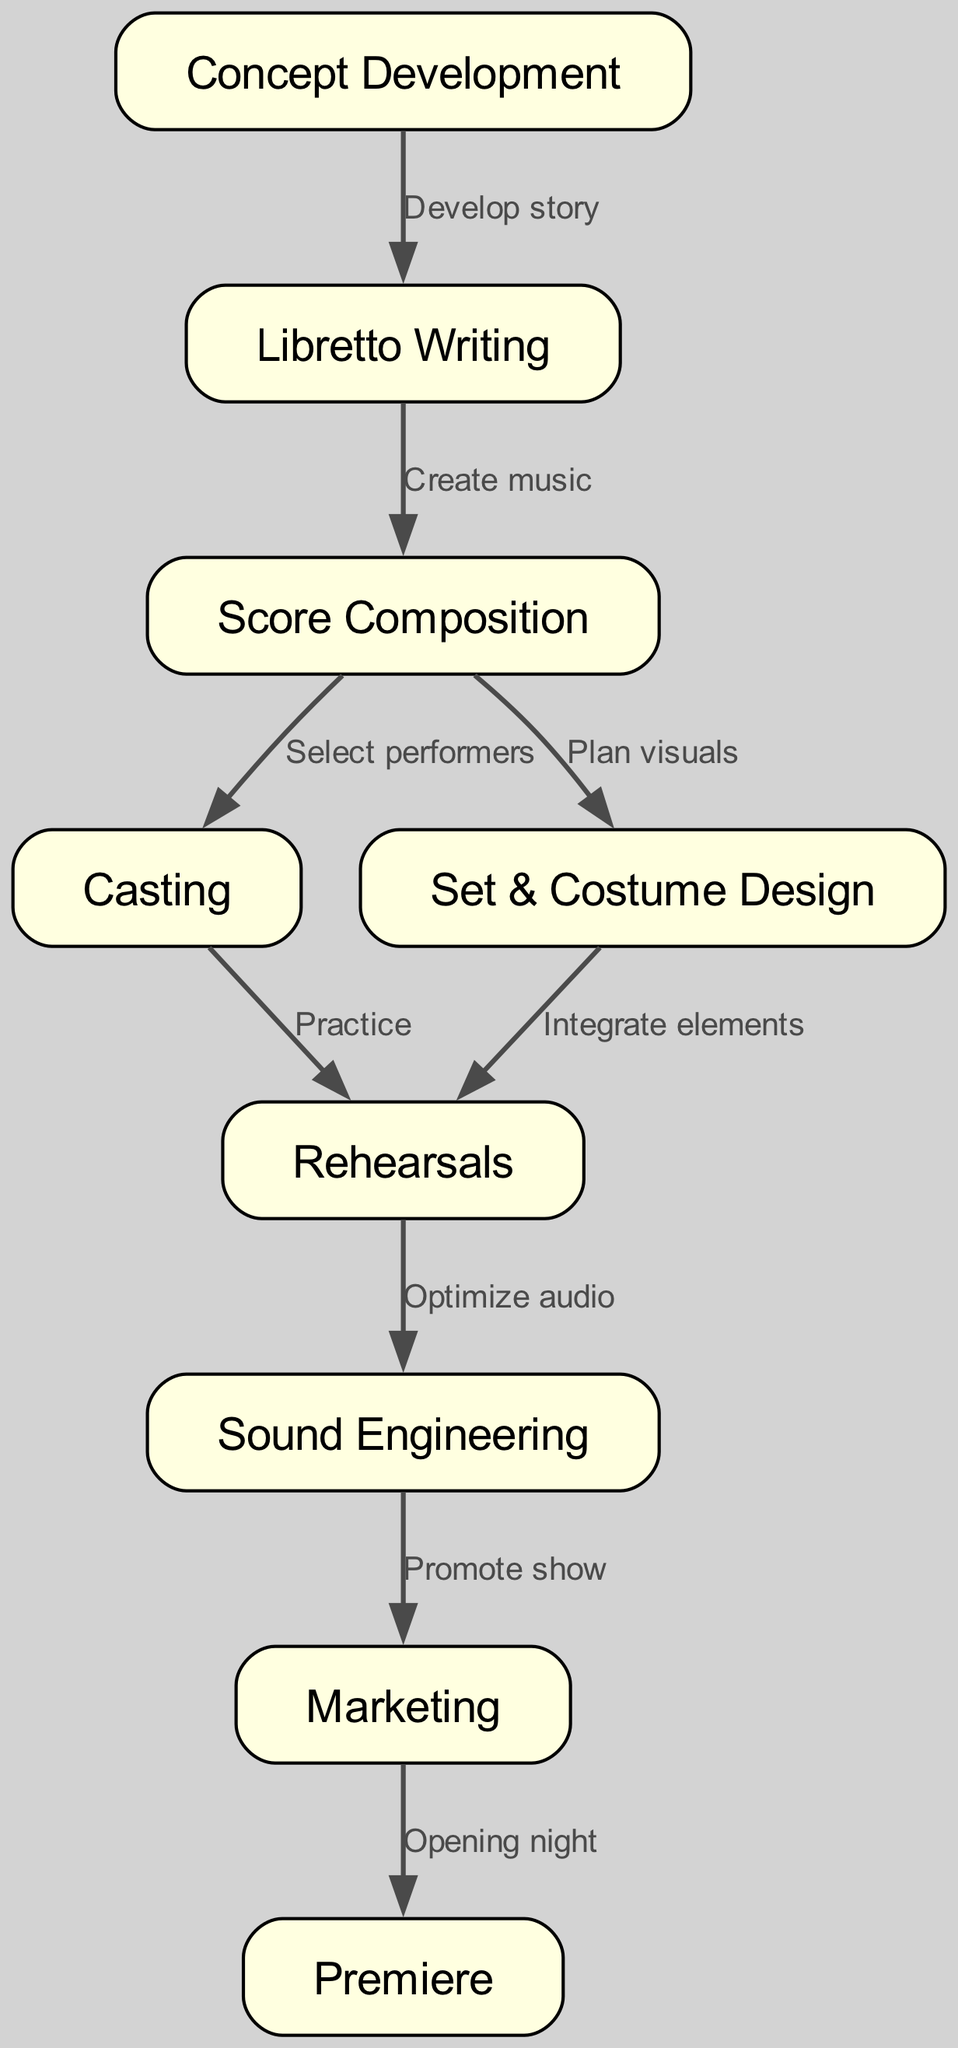What are the first two stages in modern opera production? The first two stages in the flow chart are "Concept Development" and "Libretto Writing". To determine this, we start from the top of the diagram and simply identify the first two nodes listed.
Answer: Concept Development, Libretto Writing How many total stages are depicted in the diagram? The diagram contains 9 distinct nodes, each representing a unique stage in the modern opera production process. This can be counted directly from the nodes listed in the provided data.
Answer: 9 What is the relationship between "Sound Engineering" and "Marketing"? There is no direct relationship (edge) between "Sound Engineering" and "Marketing" in the diagram. To find this, we examine the edges to see if either of these nodes leads to the other, which it does not.
Answer: None Which stage comes directly after "Rehearsals"? The stage that comes directly after "Rehearsals" is "Sound Engineering". This is identified by checking the edge that connects the "Rehearsals" node to the following node in the sequence.
Answer: Sound Engineering What is the last stage in the modern opera production process? The last stage in the process is "Premiere". By looking at the nodes, we can see that "Premiere" is the final node in the flow chart that follows the "Marketing" stage.
Answer: Premiere How many edges are in the diagram? The diagram contains 8 edges, which represent the relationships or transitions between the different stages. This can be counted directly from the edges listed in the provided data.
Answer: 8 What stage involves "Integrate elements"? The stage that involves "Integrate elements" is "Rehearsals". To answer this, we can find the edge labeled "Integrate elements", which points from "Set & Costume Design" to "Rehearsals".
Answer: Rehearsals What stage is associated with the phrase "Opening night"? The stage associated with the phrase "Opening night" is "Premiere". This can be determined by identifying the edge that points to the node "Premiere" and checking its label.
Answer: Premiere 